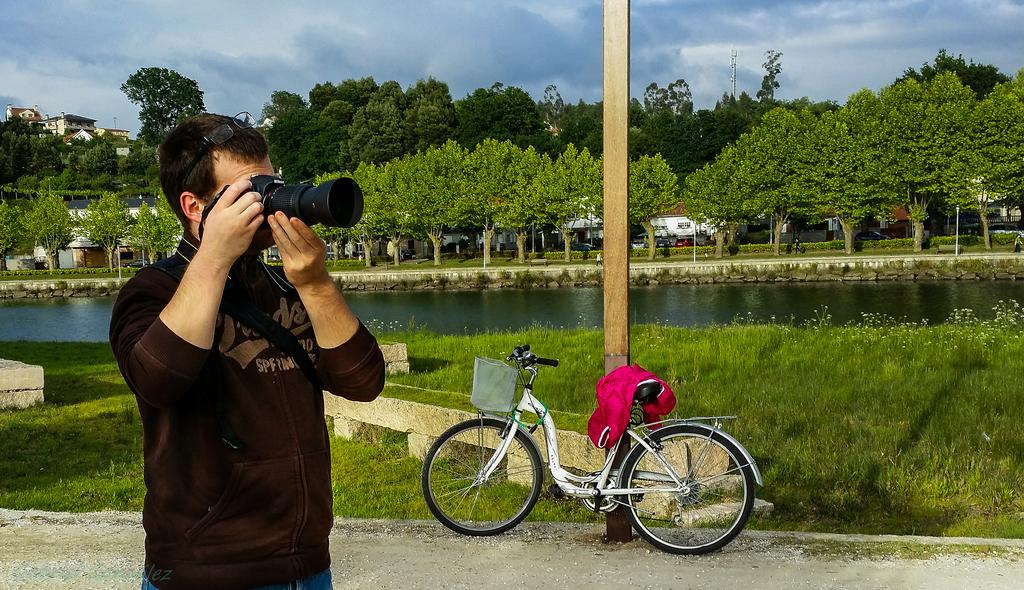What is the man in the image holding? The man is holding a camera. What object is beside the man? There is a bicycle beside the man. What can be seen in the background of the image? There is water, trees, vehicles, and buildings visible in the background. Can you describe the pole in the image? There is a pole in the image, but no additional details are provided. What type of silver basin can be seen in the image? There is no silver basin present in the image. Are there any ducks swimming in the water visible in the background? There is no mention of ducks in the image, only water and other background elements. 